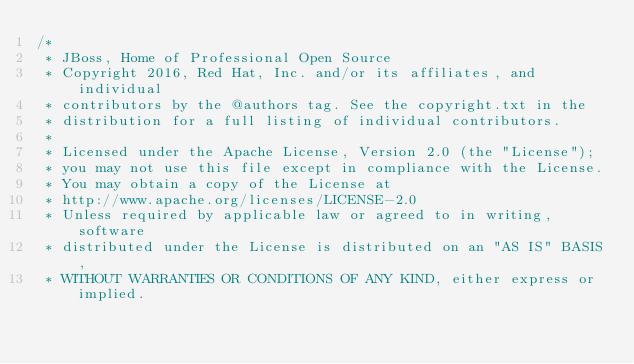Convert code to text. <code><loc_0><loc_0><loc_500><loc_500><_JavaScript_>/*
 * JBoss, Home of Professional Open Source
 * Copyright 2016, Red Hat, Inc. and/or its affiliates, and individual
 * contributors by the @authors tag. See the copyright.txt in the
 * distribution for a full listing of individual contributors.
 *
 * Licensed under the Apache License, Version 2.0 (the "License");
 * you may not use this file except in compliance with the License.
 * You may obtain a copy of the License at
 * http://www.apache.org/licenses/LICENSE-2.0
 * Unless required by applicable law or agreed to in writing, software
 * distributed under the License is distributed on an "AS IS" BASIS,
 * WITHOUT WARRANTIES OR CONDITIONS OF ANY KIND, either express or implied.</code> 